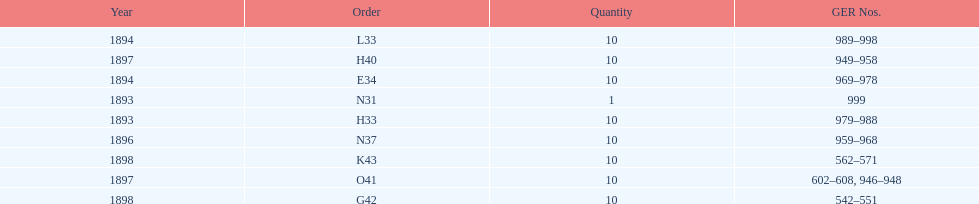Which order was the next order after l33? E34. 